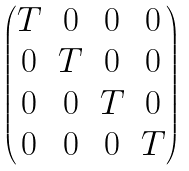Convert formula to latex. <formula><loc_0><loc_0><loc_500><loc_500>\begin{pmatrix} T & 0 & 0 & 0 \\ 0 & T & 0 & 0 \\ 0 & 0 & T & 0 \\ 0 & 0 & 0 & T \end{pmatrix}</formula> 